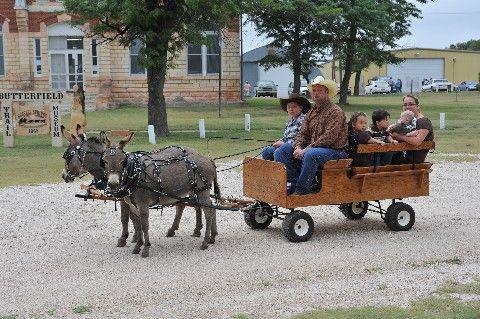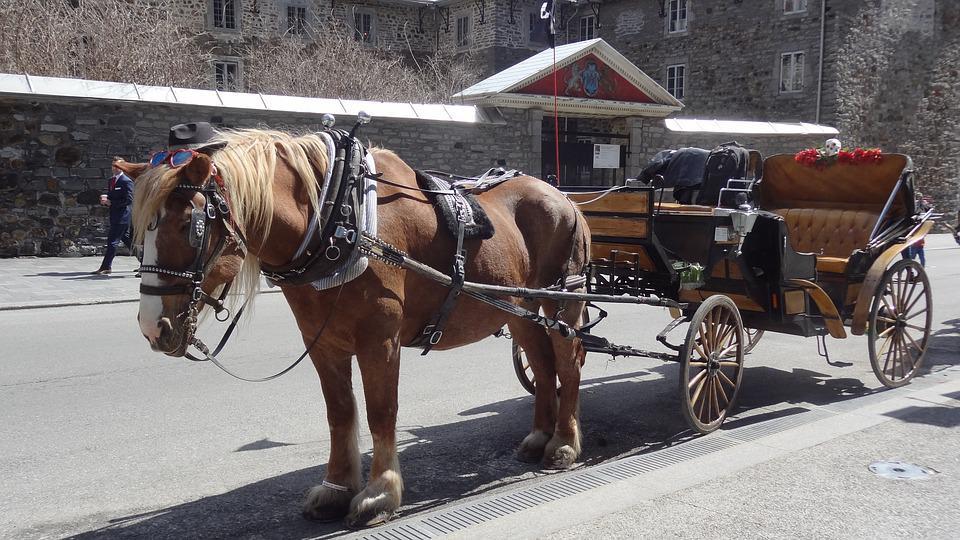The first image is the image on the left, the second image is the image on the right. Examine the images to the left and right. Is the description "The left image shows a two wheel cart without a person riding in it." accurate? Answer yes or no. No. The first image is the image on the left, the second image is the image on the right. Assess this claim about the two images: "There is at least one person in the image on the left.". Correct or not? Answer yes or no. Yes. 